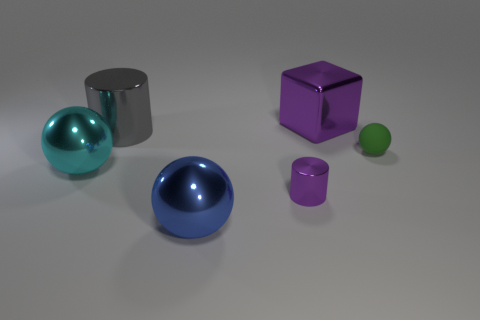Subtract all large metal spheres. How many spheres are left? 1 Add 3 tiny cyan rubber objects. How many objects exist? 9 Subtract all cyan spheres. How many spheres are left? 2 Subtract 1 spheres. How many spheres are left? 2 Subtract all cubes. How many objects are left? 5 Add 3 green spheres. How many green spheres exist? 4 Subtract 0 yellow blocks. How many objects are left? 6 Subtract all cyan blocks. Subtract all yellow spheres. How many blocks are left? 1 Subtract all red cubes. How many yellow balls are left? 0 Subtract all green matte things. Subtract all big purple cubes. How many objects are left? 4 